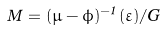Convert formula to latex. <formula><loc_0><loc_0><loc_500><loc_500>\hat { M } = ( \mu - \phi ) ^ { - 1 } ( \varepsilon ) / G</formula> 